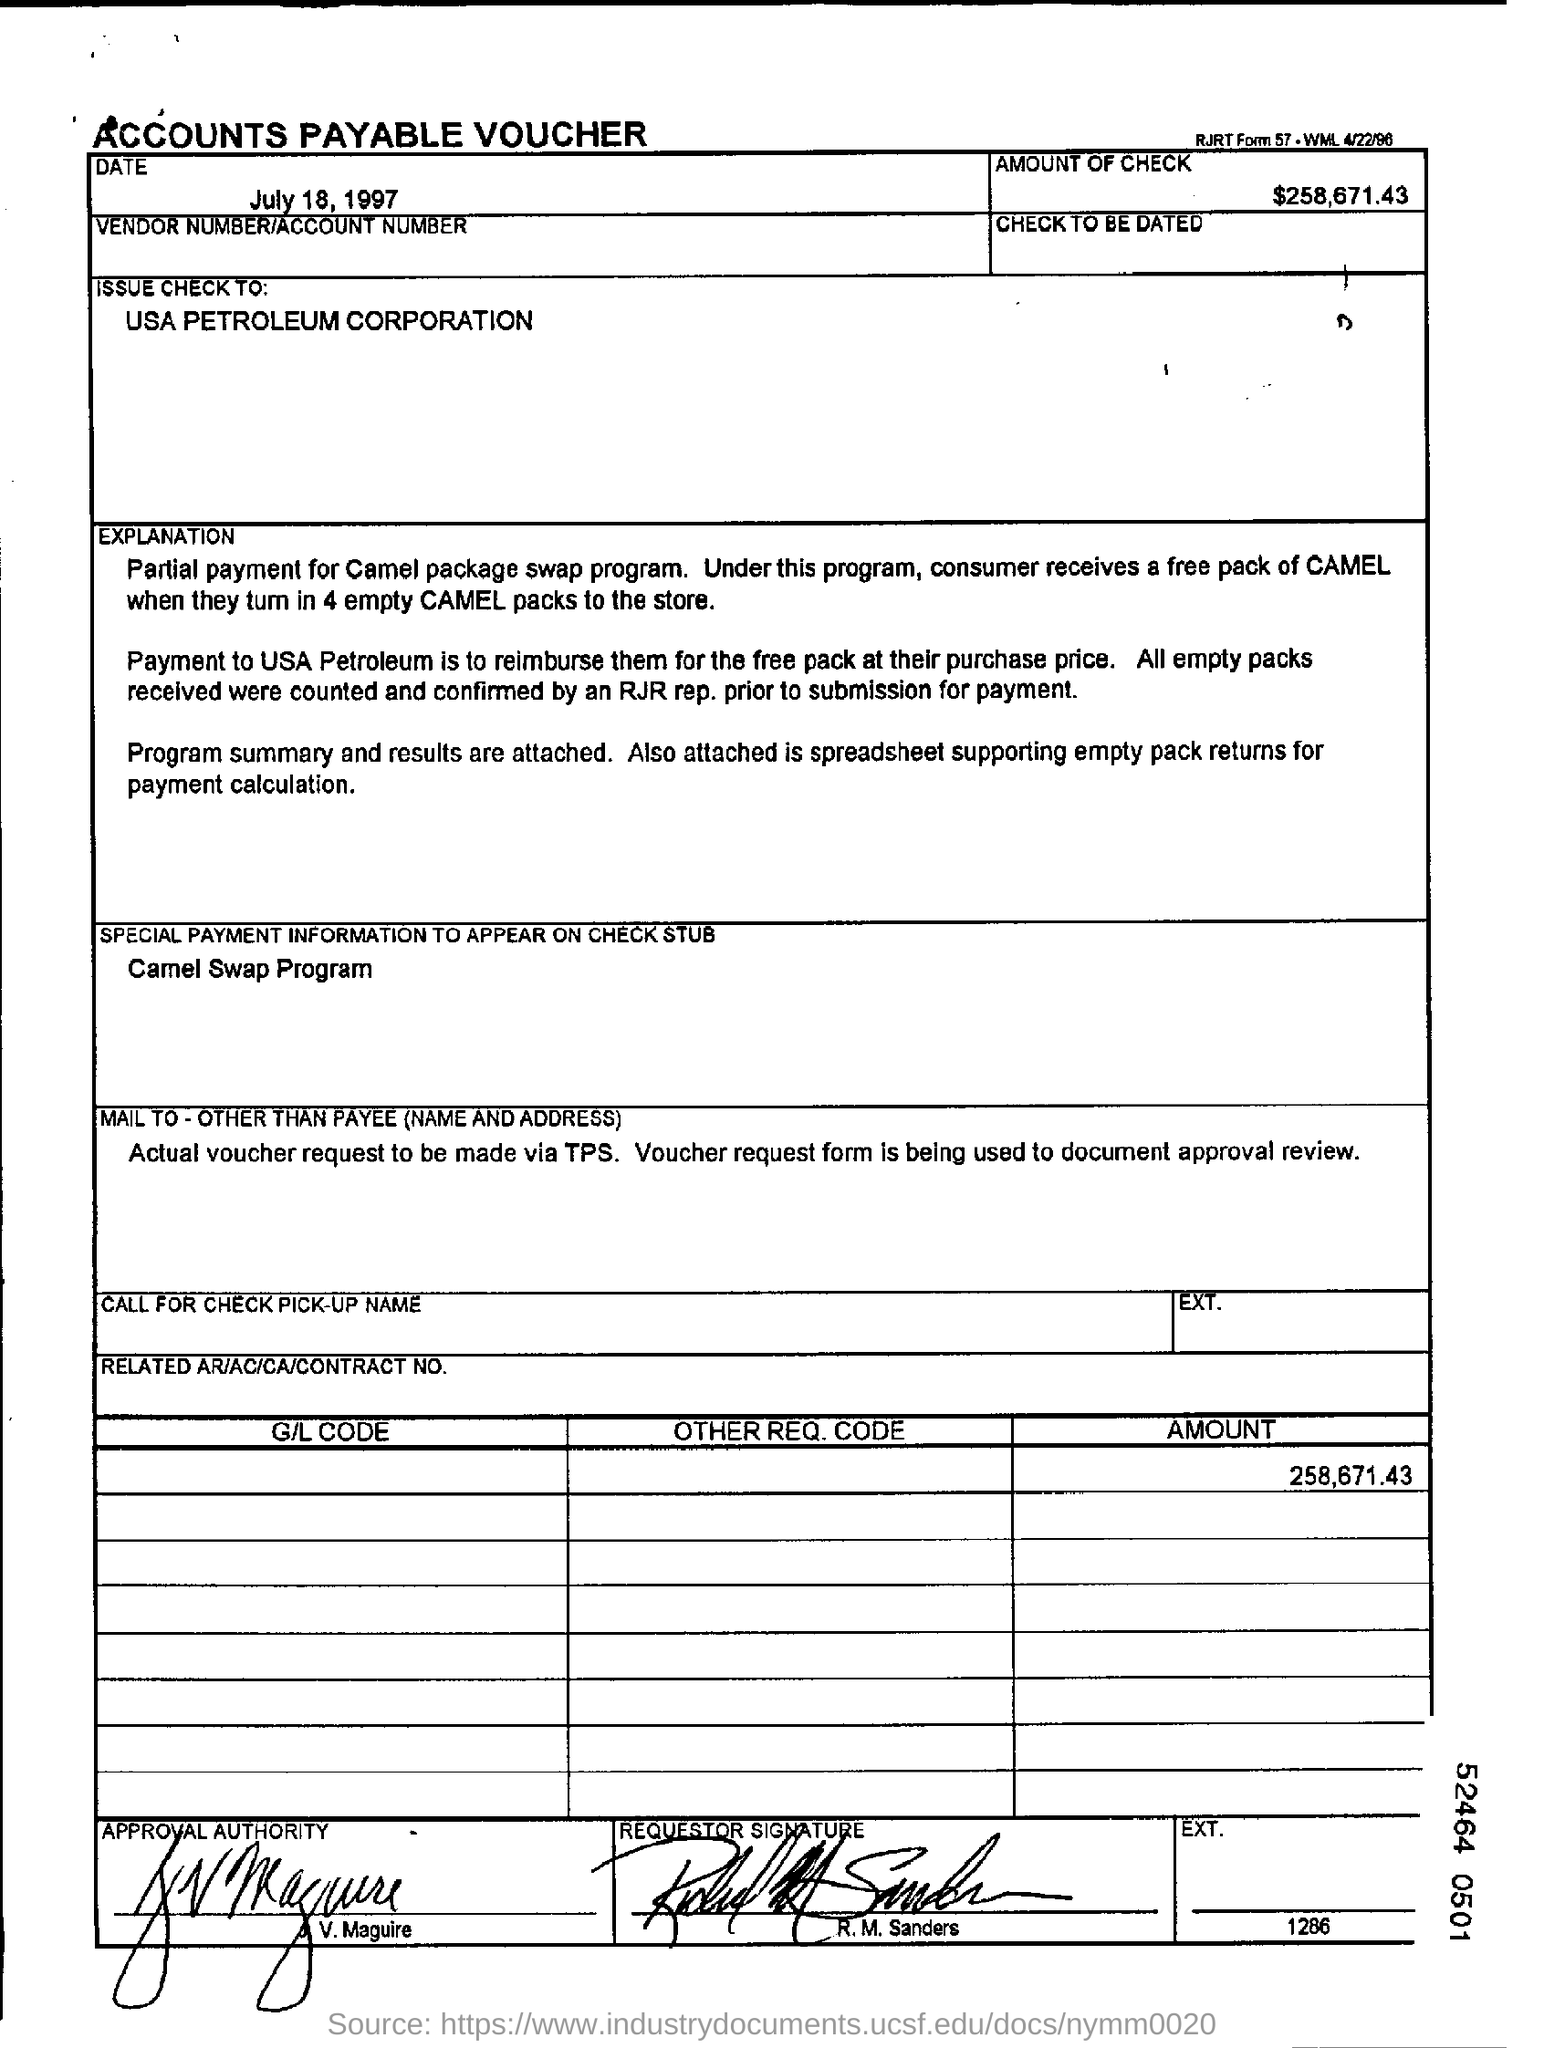Point out several critical features in this image. What is the special payment information that should appear on a check stub? Camel Swap Program... The amount on the check mentioned in the voucher is $258,671.43. The check is being issued to USA Petroleum corporation. The date mentioned in the voucher is July 18, 1997. 